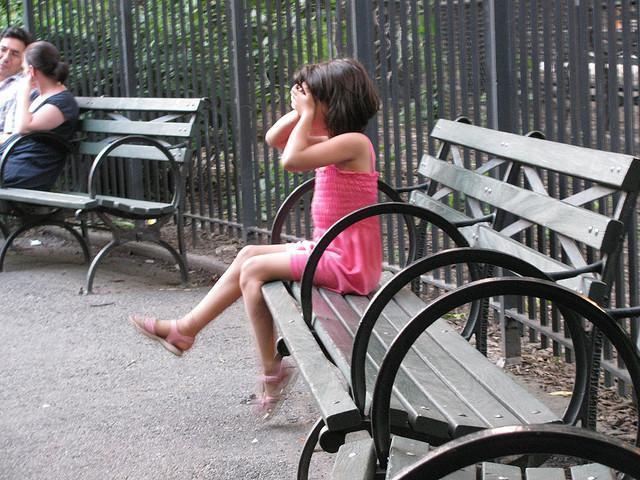How many benches can be seen?
Give a very brief answer. 3. How many people can you see?
Give a very brief answer. 3. 